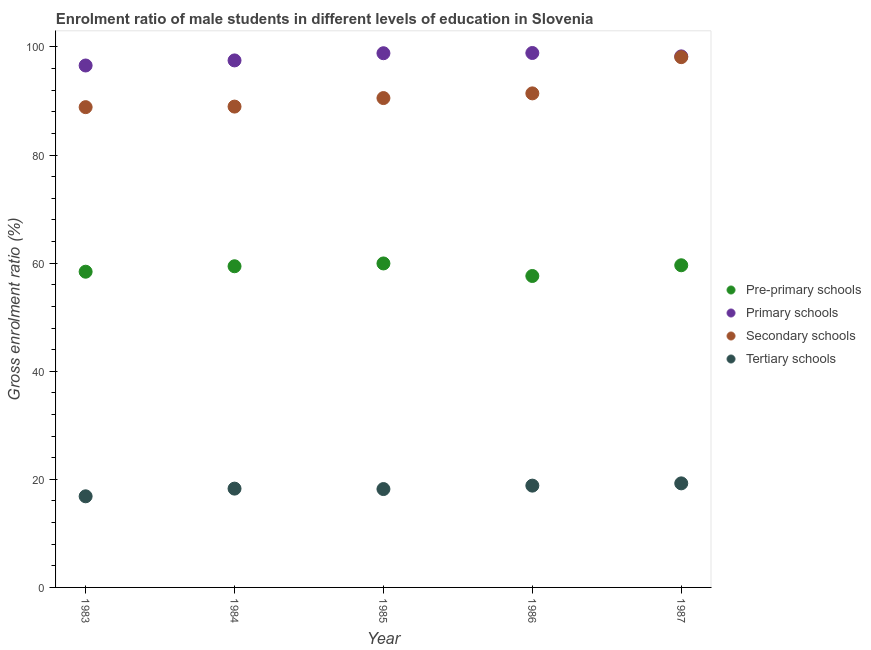How many different coloured dotlines are there?
Your response must be concise. 4. Is the number of dotlines equal to the number of legend labels?
Your answer should be very brief. Yes. What is the gross enrolment ratio(female) in tertiary schools in 1984?
Offer a very short reply. 18.28. Across all years, what is the maximum gross enrolment ratio(female) in primary schools?
Your response must be concise. 98.89. Across all years, what is the minimum gross enrolment ratio(female) in primary schools?
Your response must be concise. 96.58. In which year was the gross enrolment ratio(female) in secondary schools minimum?
Offer a terse response. 1983. What is the total gross enrolment ratio(female) in primary schools in the graph?
Offer a terse response. 490.1. What is the difference between the gross enrolment ratio(female) in pre-primary schools in 1984 and that in 1985?
Your response must be concise. -0.52. What is the difference between the gross enrolment ratio(female) in tertiary schools in 1987 and the gross enrolment ratio(female) in secondary schools in 1983?
Make the answer very short. -69.62. What is the average gross enrolment ratio(female) in primary schools per year?
Make the answer very short. 98.02. In the year 1986, what is the difference between the gross enrolment ratio(female) in tertiary schools and gross enrolment ratio(female) in pre-primary schools?
Make the answer very short. -38.79. In how many years, is the gross enrolment ratio(female) in pre-primary schools greater than 16 %?
Offer a terse response. 5. What is the ratio of the gross enrolment ratio(female) in pre-primary schools in 1984 to that in 1987?
Offer a terse response. 1. Is the difference between the gross enrolment ratio(female) in primary schools in 1984 and 1985 greater than the difference between the gross enrolment ratio(female) in secondary schools in 1984 and 1985?
Your answer should be compact. Yes. What is the difference between the highest and the second highest gross enrolment ratio(female) in primary schools?
Offer a terse response. 0.04. What is the difference between the highest and the lowest gross enrolment ratio(female) in secondary schools?
Ensure brevity in your answer.  9.25. In how many years, is the gross enrolment ratio(female) in tertiary schools greater than the average gross enrolment ratio(female) in tertiary schools taken over all years?
Offer a very short reply. 2. Does the gross enrolment ratio(female) in secondary schools monotonically increase over the years?
Keep it short and to the point. Yes. Is the gross enrolment ratio(female) in secondary schools strictly greater than the gross enrolment ratio(female) in pre-primary schools over the years?
Your response must be concise. Yes. How many years are there in the graph?
Give a very brief answer. 5. Are the values on the major ticks of Y-axis written in scientific E-notation?
Your answer should be very brief. No. How many legend labels are there?
Provide a succinct answer. 4. How are the legend labels stacked?
Provide a short and direct response. Vertical. What is the title of the graph?
Keep it short and to the point. Enrolment ratio of male students in different levels of education in Slovenia. Does "Secondary general education" appear as one of the legend labels in the graph?
Your answer should be compact. No. What is the label or title of the Y-axis?
Provide a short and direct response. Gross enrolment ratio (%). What is the Gross enrolment ratio (%) of Pre-primary schools in 1983?
Give a very brief answer. 58.42. What is the Gross enrolment ratio (%) in Primary schools in 1983?
Ensure brevity in your answer.  96.58. What is the Gross enrolment ratio (%) in Secondary schools in 1983?
Your answer should be compact. 88.87. What is the Gross enrolment ratio (%) in Tertiary schools in 1983?
Make the answer very short. 16.86. What is the Gross enrolment ratio (%) of Pre-primary schools in 1984?
Keep it short and to the point. 59.43. What is the Gross enrolment ratio (%) in Primary schools in 1984?
Make the answer very short. 97.52. What is the Gross enrolment ratio (%) of Secondary schools in 1984?
Ensure brevity in your answer.  88.97. What is the Gross enrolment ratio (%) of Tertiary schools in 1984?
Provide a short and direct response. 18.28. What is the Gross enrolment ratio (%) in Pre-primary schools in 1985?
Offer a terse response. 59.95. What is the Gross enrolment ratio (%) in Primary schools in 1985?
Provide a short and direct response. 98.85. What is the Gross enrolment ratio (%) of Secondary schools in 1985?
Your answer should be compact. 90.55. What is the Gross enrolment ratio (%) of Tertiary schools in 1985?
Your response must be concise. 18.2. What is the Gross enrolment ratio (%) in Pre-primary schools in 1986?
Your answer should be compact. 57.63. What is the Gross enrolment ratio (%) in Primary schools in 1986?
Offer a terse response. 98.89. What is the Gross enrolment ratio (%) in Secondary schools in 1986?
Provide a succinct answer. 91.42. What is the Gross enrolment ratio (%) in Tertiary schools in 1986?
Offer a terse response. 18.84. What is the Gross enrolment ratio (%) of Pre-primary schools in 1987?
Make the answer very short. 59.61. What is the Gross enrolment ratio (%) in Primary schools in 1987?
Keep it short and to the point. 98.27. What is the Gross enrolment ratio (%) in Secondary schools in 1987?
Offer a very short reply. 98.12. What is the Gross enrolment ratio (%) of Tertiary schools in 1987?
Your response must be concise. 19.25. Across all years, what is the maximum Gross enrolment ratio (%) of Pre-primary schools?
Provide a succinct answer. 59.95. Across all years, what is the maximum Gross enrolment ratio (%) in Primary schools?
Give a very brief answer. 98.89. Across all years, what is the maximum Gross enrolment ratio (%) in Secondary schools?
Provide a succinct answer. 98.12. Across all years, what is the maximum Gross enrolment ratio (%) of Tertiary schools?
Your response must be concise. 19.25. Across all years, what is the minimum Gross enrolment ratio (%) in Pre-primary schools?
Ensure brevity in your answer.  57.63. Across all years, what is the minimum Gross enrolment ratio (%) in Primary schools?
Make the answer very short. 96.58. Across all years, what is the minimum Gross enrolment ratio (%) of Secondary schools?
Offer a very short reply. 88.87. Across all years, what is the minimum Gross enrolment ratio (%) of Tertiary schools?
Ensure brevity in your answer.  16.86. What is the total Gross enrolment ratio (%) in Pre-primary schools in the graph?
Your answer should be very brief. 295.04. What is the total Gross enrolment ratio (%) in Primary schools in the graph?
Ensure brevity in your answer.  490.1. What is the total Gross enrolment ratio (%) of Secondary schools in the graph?
Your answer should be compact. 457.93. What is the total Gross enrolment ratio (%) in Tertiary schools in the graph?
Give a very brief answer. 91.44. What is the difference between the Gross enrolment ratio (%) of Pre-primary schools in 1983 and that in 1984?
Provide a succinct answer. -1.01. What is the difference between the Gross enrolment ratio (%) in Primary schools in 1983 and that in 1984?
Your answer should be very brief. -0.94. What is the difference between the Gross enrolment ratio (%) of Secondary schools in 1983 and that in 1984?
Provide a short and direct response. -0.1. What is the difference between the Gross enrolment ratio (%) of Tertiary schools in 1983 and that in 1984?
Ensure brevity in your answer.  -1.42. What is the difference between the Gross enrolment ratio (%) of Pre-primary schools in 1983 and that in 1985?
Provide a succinct answer. -1.53. What is the difference between the Gross enrolment ratio (%) of Primary schools in 1983 and that in 1985?
Offer a very short reply. -2.27. What is the difference between the Gross enrolment ratio (%) of Secondary schools in 1983 and that in 1985?
Your response must be concise. -1.68. What is the difference between the Gross enrolment ratio (%) of Tertiary schools in 1983 and that in 1985?
Give a very brief answer. -1.34. What is the difference between the Gross enrolment ratio (%) of Pre-primary schools in 1983 and that in 1986?
Your response must be concise. 0.79. What is the difference between the Gross enrolment ratio (%) in Primary schools in 1983 and that in 1986?
Ensure brevity in your answer.  -2.31. What is the difference between the Gross enrolment ratio (%) in Secondary schools in 1983 and that in 1986?
Provide a succinct answer. -2.55. What is the difference between the Gross enrolment ratio (%) of Tertiary schools in 1983 and that in 1986?
Your response must be concise. -1.97. What is the difference between the Gross enrolment ratio (%) in Pre-primary schools in 1983 and that in 1987?
Your answer should be very brief. -1.19. What is the difference between the Gross enrolment ratio (%) in Primary schools in 1983 and that in 1987?
Give a very brief answer. -1.69. What is the difference between the Gross enrolment ratio (%) of Secondary schools in 1983 and that in 1987?
Your response must be concise. -9.25. What is the difference between the Gross enrolment ratio (%) in Tertiary schools in 1983 and that in 1987?
Make the answer very short. -2.39. What is the difference between the Gross enrolment ratio (%) in Pre-primary schools in 1984 and that in 1985?
Provide a succinct answer. -0.52. What is the difference between the Gross enrolment ratio (%) in Primary schools in 1984 and that in 1985?
Keep it short and to the point. -1.33. What is the difference between the Gross enrolment ratio (%) in Secondary schools in 1984 and that in 1985?
Provide a succinct answer. -1.58. What is the difference between the Gross enrolment ratio (%) of Tertiary schools in 1984 and that in 1985?
Your answer should be compact. 0.08. What is the difference between the Gross enrolment ratio (%) of Pre-primary schools in 1984 and that in 1986?
Keep it short and to the point. 1.8. What is the difference between the Gross enrolment ratio (%) in Primary schools in 1984 and that in 1986?
Keep it short and to the point. -1.37. What is the difference between the Gross enrolment ratio (%) of Secondary schools in 1984 and that in 1986?
Keep it short and to the point. -2.44. What is the difference between the Gross enrolment ratio (%) of Tertiary schools in 1984 and that in 1986?
Your response must be concise. -0.55. What is the difference between the Gross enrolment ratio (%) of Pre-primary schools in 1984 and that in 1987?
Provide a succinct answer. -0.18. What is the difference between the Gross enrolment ratio (%) of Primary schools in 1984 and that in 1987?
Your answer should be compact. -0.75. What is the difference between the Gross enrolment ratio (%) in Secondary schools in 1984 and that in 1987?
Give a very brief answer. -9.15. What is the difference between the Gross enrolment ratio (%) of Tertiary schools in 1984 and that in 1987?
Your answer should be very brief. -0.97. What is the difference between the Gross enrolment ratio (%) in Pre-primary schools in 1985 and that in 1986?
Your answer should be compact. 2.32. What is the difference between the Gross enrolment ratio (%) of Primary schools in 1985 and that in 1986?
Your response must be concise. -0.04. What is the difference between the Gross enrolment ratio (%) of Secondary schools in 1985 and that in 1986?
Keep it short and to the point. -0.87. What is the difference between the Gross enrolment ratio (%) in Tertiary schools in 1985 and that in 1986?
Your answer should be compact. -0.63. What is the difference between the Gross enrolment ratio (%) of Pre-primary schools in 1985 and that in 1987?
Your answer should be very brief. 0.34. What is the difference between the Gross enrolment ratio (%) in Primary schools in 1985 and that in 1987?
Keep it short and to the point. 0.58. What is the difference between the Gross enrolment ratio (%) in Secondary schools in 1985 and that in 1987?
Your response must be concise. -7.57. What is the difference between the Gross enrolment ratio (%) of Tertiary schools in 1985 and that in 1987?
Offer a very short reply. -1.05. What is the difference between the Gross enrolment ratio (%) of Pre-primary schools in 1986 and that in 1987?
Make the answer very short. -1.98. What is the difference between the Gross enrolment ratio (%) in Primary schools in 1986 and that in 1987?
Offer a terse response. 0.62. What is the difference between the Gross enrolment ratio (%) of Secondary schools in 1986 and that in 1987?
Give a very brief answer. -6.7. What is the difference between the Gross enrolment ratio (%) of Tertiary schools in 1986 and that in 1987?
Provide a succinct answer. -0.42. What is the difference between the Gross enrolment ratio (%) of Pre-primary schools in 1983 and the Gross enrolment ratio (%) of Primary schools in 1984?
Provide a short and direct response. -39.1. What is the difference between the Gross enrolment ratio (%) of Pre-primary schools in 1983 and the Gross enrolment ratio (%) of Secondary schools in 1984?
Give a very brief answer. -30.55. What is the difference between the Gross enrolment ratio (%) in Pre-primary schools in 1983 and the Gross enrolment ratio (%) in Tertiary schools in 1984?
Your answer should be compact. 40.14. What is the difference between the Gross enrolment ratio (%) of Primary schools in 1983 and the Gross enrolment ratio (%) of Secondary schools in 1984?
Provide a short and direct response. 7.6. What is the difference between the Gross enrolment ratio (%) in Primary schools in 1983 and the Gross enrolment ratio (%) in Tertiary schools in 1984?
Provide a succinct answer. 78.29. What is the difference between the Gross enrolment ratio (%) in Secondary schools in 1983 and the Gross enrolment ratio (%) in Tertiary schools in 1984?
Your answer should be very brief. 70.59. What is the difference between the Gross enrolment ratio (%) of Pre-primary schools in 1983 and the Gross enrolment ratio (%) of Primary schools in 1985?
Offer a terse response. -40.43. What is the difference between the Gross enrolment ratio (%) of Pre-primary schools in 1983 and the Gross enrolment ratio (%) of Secondary schools in 1985?
Ensure brevity in your answer.  -32.13. What is the difference between the Gross enrolment ratio (%) in Pre-primary schools in 1983 and the Gross enrolment ratio (%) in Tertiary schools in 1985?
Your response must be concise. 40.22. What is the difference between the Gross enrolment ratio (%) in Primary schools in 1983 and the Gross enrolment ratio (%) in Secondary schools in 1985?
Provide a succinct answer. 6.03. What is the difference between the Gross enrolment ratio (%) of Primary schools in 1983 and the Gross enrolment ratio (%) of Tertiary schools in 1985?
Ensure brevity in your answer.  78.38. What is the difference between the Gross enrolment ratio (%) of Secondary schools in 1983 and the Gross enrolment ratio (%) of Tertiary schools in 1985?
Offer a terse response. 70.67. What is the difference between the Gross enrolment ratio (%) of Pre-primary schools in 1983 and the Gross enrolment ratio (%) of Primary schools in 1986?
Ensure brevity in your answer.  -40.47. What is the difference between the Gross enrolment ratio (%) in Pre-primary schools in 1983 and the Gross enrolment ratio (%) in Secondary schools in 1986?
Your response must be concise. -33. What is the difference between the Gross enrolment ratio (%) in Pre-primary schools in 1983 and the Gross enrolment ratio (%) in Tertiary schools in 1986?
Offer a very short reply. 39.58. What is the difference between the Gross enrolment ratio (%) in Primary schools in 1983 and the Gross enrolment ratio (%) in Secondary schools in 1986?
Your answer should be very brief. 5.16. What is the difference between the Gross enrolment ratio (%) of Primary schools in 1983 and the Gross enrolment ratio (%) of Tertiary schools in 1986?
Make the answer very short. 77.74. What is the difference between the Gross enrolment ratio (%) of Secondary schools in 1983 and the Gross enrolment ratio (%) of Tertiary schools in 1986?
Provide a succinct answer. 70.03. What is the difference between the Gross enrolment ratio (%) in Pre-primary schools in 1983 and the Gross enrolment ratio (%) in Primary schools in 1987?
Your answer should be very brief. -39.85. What is the difference between the Gross enrolment ratio (%) in Pre-primary schools in 1983 and the Gross enrolment ratio (%) in Secondary schools in 1987?
Offer a terse response. -39.7. What is the difference between the Gross enrolment ratio (%) in Pre-primary schools in 1983 and the Gross enrolment ratio (%) in Tertiary schools in 1987?
Make the answer very short. 39.17. What is the difference between the Gross enrolment ratio (%) of Primary schools in 1983 and the Gross enrolment ratio (%) of Secondary schools in 1987?
Make the answer very short. -1.54. What is the difference between the Gross enrolment ratio (%) of Primary schools in 1983 and the Gross enrolment ratio (%) of Tertiary schools in 1987?
Your answer should be compact. 77.32. What is the difference between the Gross enrolment ratio (%) in Secondary schools in 1983 and the Gross enrolment ratio (%) in Tertiary schools in 1987?
Keep it short and to the point. 69.61. What is the difference between the Gross enrolment ratio (%) of Pre-primary schools in 1984 and the Gross enrolment ratio (%) of Primary schools in 1985?
Your answer should be compact. -39.42. What is the difference between the Gross enrolment ratio (%) in Pre-primary schools in 1984 and the Gross enrolment ratio (%) in Secondary schools in 1985?
Your answer should be compact. -31.12. What is the difference between the Gross enrolment ratio (%) of Pre-primary schools in 1984 and the Gross enrolment ratio (%) of Tertiary schools in 1985?
Provide a succinct answer. 41.23. What is the difference between the Gross enrolment ratio (%) of Primary schools in 1984 and the Gross enrolment ratio (%) of Secondary schools in 1985?
Provide a short and direct response. 6.97. What is the difference between the Gross enrolment ratio (%) in Primary schools in 1984 and the Gross enrolment ratio (%) in Tertiary schools in 1985?
Keep it short and to the point. 79.31. What is the difference between the Gross enrolment ratio (%) of Secondary schools in 1984 and the Gross enrolment ratio (%) of Tertiary schools in 1985?
Provide a succinct answer. 70.77. What is the difference between the Gross enrolment ratio (%) in Pre-primary schools in 1984 and the Gross enrolment ratio (%) in Primary schools in 1986?
Offer a terse response. -39.46. What is the difference between the Gross enrolment ratio (%) in Pre-primary schools in 1984 and the Gross enrolment ratio (%) in Secondary schools in 1986?
Your response must be concise. -31.99. What is the difference between the Gross enrolment ratio (%) of Pre-primary schools in 1984 and the Gross enrolment ratio (%) of Tertiary schools in 1986?
Your response must be concise. 40.59. What is the difference between the Gross enrolment ratio (%) of Primary schools in 1984 and the Gross enrolment ratio (%) of Secondary schools in 1986?
Your answer should be compact. 6.1. What is the difference between the Gross enrolment ratio (%) in Primary schools in 1984 and the Gross enrolment ratio (%) in Tertiary schools in 1986?
Your answer should be compact. 78.68. What is the difference between the Gross enrolment ratio (%) of Secondary schools in 1984 and the Gross enrolment ratio (%) of Tertiary schools in 1986?
Your answer should be very brief. 70.14. What is the difference between the Gross enrolment ratio (%) in Pre-primary schools in 1984 and the Gross enrolment ratio (%) in Primary schools in 1987?
Give a very brief answer. -38.84. What is the difference between the Gross enrolment ratio (%) of Pre-primary schools in 1984 and the Gross enrolment ratio (%) of Secondary schools in 1987?
Provide a succinct answer. -38.69. What is the difference between the Gross enrolment ratio (%) of Pre-primary schools in 1984 and the Gross enrolment ratio (%) of Tertiary schools in 1987?
Your response must be concise. 40.17. What is the difference between the Gross enrolment ratio (%) of Primary schools in 1984 and the Gross enrolment ratio (%) of Secondary schools in 1987?
Provide a short and direct response. -0.6. What is the difference between the Gross enrolment ratio (%) of Primary schools in 1984 and the Gross enrolment ratio (%) of Tertiary schools in 1987?
Provide a short and direct response. 78.26. What is the difference between the Gross enrolment ratio (%) in Secondary schools in 1984 and the Gross enrolment ratio (%) in Tertiary schools in 1987?
Provide a short and direct response. 69.72. What is the difference between the Gross enrolment ratio (%) of Pre-primary schools in 1985 and the Gross enrolment ratio (%) of Primary schools in 1986?
Ensure brevity in your answer.  -38.94. What is the difference between the Gross enrolment ratio (%) in Pre-primary schools in 1985 and the Gross enrolment ratio (%) in Secondary schools in 1986?
Make the answer very short. -31.47. What is the difference between the Gross enrolment ratio (%) in Pre-primary schools in 1985 and the Gross enrolment ratio (%) in Tertiary schools in 1986?
Offer a terse response. 41.11. What is the difference between the Gross enrolment ratio (%) of Primary schools in 1985 and the Gross enrolment ratio (%) of Secondary schools in 1986?
Provide a succinct answer. 7.43. What is the difference between the Gross enrolment ratio (%) of Primary schools in 1985 and the Gross enrolment ratio (%) of Tertiary schools in 1986?
Keep it short and to the point. 80.01. What is the difference between the Gross enrolment ratio (%) in Secondary schools in 1985 and the Gross enrolment ratio (%) in Tertiary schools in 1986?
Ensure brevity in your answer.  71.71. What is the difference between the Gross enrolment ratio (%) of Pre-primary schools in 1985 and the Gross enrolment ratio (%) of Primary schools in 1987?
Your response must be concise. -38.32. What is the difference between the Gross enrolment ratio (%) of Pre-primary schools in 1985 and the Gross enrolment ratio (%) of Secondary schools in 1987?
Your response must be concise. -38.17. What is the difference between the Gross enrolment ratio (%) in Pre-primary schools in 1985 and the Gross enrolment ratio (%) in Tertiary schools in 1987?
Provide a short and direct response. 40.69. What is the difference between the Gross enrolment ratio (%) of Primary schools in 1985 and the Gross enrolment ratio (%) of Secondary schools in 1987?
Provide a succinct answer. 0.73. What is the difference between the Gross enrolment ratio (%) of Primary schools in 1985 and the Gross enrolment ratio (%) of Tertiary schools in 1987?
Keep it short and to the point. 79.59. What is the difference between the Gross enrolment ratio (%) in Secondary schools in 1985 and the Gross enrolment ratio (%) in Tertiary schools in 1987?
Your answer should be very brief. 71.3. What is the difference between the Gross enrolment ratio (%) of Pre-primary schools in 1986 and the Gross enrolment ratio (%) of Primary schools in 1987?
Ensure brevity in your answer.  -40.64. What is the difference between the Gross enrolment ratio (%) of Pre-primary schools in 1986 and the Gross enrolment ratio (%) of Secondary schools in 1987?
Offer a terse response. -40.49. What is the difference between the Gross enrolment ratio (%) in Pre-primary schools in 1986 and the Gross enrolment ratio (%) in Tertiary schools in 1987?
Provide a short and direct response. 38.37. What is the difference between the Gross enrolment ratio (%) in Primary schools in 1986 and the Gross enrolment ratio (%) in Secondary schools in 1987?
Offer a very short reply. 0.77. What is the difference between the Gross enrolment ratio (%) of Primary schools in 1986 and the Gross enrolment ratio (%) of Tertiary schools in 1987?
Make the answer very short. 79.64. What is the difference between the Gross enrolment ratio (%) of Secondary schools in 1986 and the Gross enrolment ratio (%) of Tertiary schools in 1987?
Ensure brevity in your answer.  72.16. What is the average Gross enrolment ratio (%) of Pre-primary schools per year?
Your response must be concise. 59.01. What is the average Gross enrolment ratio (%) in Primary schools per year?
Your answer should be very brief. 98.02. What is the average Gross enrolment ratio (%) of Secondary schools per year?
Provide a short and direct response. 91.59. What is the average Gross enrolment ratio (%) of Tertiary schools per year?
Offer a very short reply. 18.29. In the year 1983, what is the difference between the Gross enrolment ratio (%) in Pre-primary schools and Gross enrolment ratio (%) in Primary schools?
Your answer should be compact. -38.16. In the year 1983, what is the difference between the Gross enrolment ratio (%) in Pre-primary schools and Gross enrolment ratio (%) in Secondary schools?
Ensure brevity in your answer.  -30.45. In the year 1983, what is the difference between the Gross enrolment ratio (%) in Pre-primary schools and Gross enrolment ratio (%) in Tertiary schools?
Make the answer very short. 41.56. In the year 1983, what is the difference between the Gross enrolment ratio (%) in Primary schools and Gross enrolment ratio (%) in Secondary schools?
Offer a very short reply. 7.71. In the year 1983, what is the difference between the Gross enrolment ratio (%) of Primary schools and Gross enrolment ratio (%) of Tertiary schools?
Your response must be concise. 79.72. In the year 1983, what is the difference between the Gross enrolment ratio (%) of Secondary schools and Gross enrolment ratio (%) of Tertiary schools?
Provide a short and direct response. 72.01. In the year 1984, what is the difference between the Gross enrolment ratio (%) of Pre-primary schools and Gross enrolment ratio (%) of Primary schools?
Your answer should be compact. -38.09. In the year 1984, what is the difference between the Gross enrolment ratio (%) of Pre-primary schools and Gross enrolment ratio (%) of Secondary schools?
Offer a very short reply. -29.54. In the year 1984, what is the difference between the Gross enrolment ratio (%) in Pre-primary schools and Gross enrolment ratio (%) in Tertiary schools?
Provide a short and direct response. 41.15. In the year 1984, what is the difference between the Gross enrolment ratio (%) in Primary schools and Gross enrolment ratio (%) in Secondary schools?
Your response must be concise. 8.54. In the year 1984, what is the difference between the Gross enrolment ratio (%) of Primary schools and Gross enrolment ratio (%) of Tertiary schools?
Provide a short and direct response. 79.23. In the year 1984, what is the difference between the Gross enrolment ratio (%) of Secondary schools and Gross enrolment ratio (%) of Tertiary schools?
Provide a succinct answer. 70.69. In the year 1985, what is the difference between the Gross enrolment ratio (%) in Pre-primary schools and Gross enrolment ratio (%) in Primary schools?
Your response must be concise. -38.9. In the year 1985, what is the difference between the Gross enrolment ratio (%) of Pre-primary schools and Gross enrolment ratio (%) of Secondary schools?
Provide a succinct answer. -30.6. In the year 1985, what is the difference between the Gross enrolment ratio (%) of Pre-primary schools and Gross enrolment ratio (%) of Tertiary schools?
Make the answer very short. 41.75. In the year 1985, what is the difference between the Gross enrolment ratio (%) of Primary schools and Gross enrolment ratio (%) of Secondary schools?
Give a very brief answer. 8.3. In the year 1985, what is the difference between the Gross enrolment ratio (%) in Primary schools and Gross enrolment ratio (%) in Tertiary schools?
Give a very brief answer. 80.65. In the year 1985, what is the difference between the Gross enrolment ratio (%) in Secondary schools and Gross enrolment ratio (%) in Tertiary schools?
Offer a terse response. 72.35. In the year 1986, what is the difference between the Gross enrolment ratio (%) in Pre-primary schools and Gross enrolment ratio (%) in Primary schools?
Ensure brevity in your answer.  -41.26. In the year 1986, what is the difference between the Gross enrolment ratio (%) of Pre-primary schools and Gross enrolment ratio (%) of Secondary schools?
Offer a very short reply. -33.79. In the year 1986, what is the difference between the Gross enrolment ratio (%) of Pre-primary schools and Gross enrolment ratio (%) of Tertiary schools?
Your answer should be compact. 38.79. In the year 1986, what is the difference between the Gross enrolment ratio (%) of Primary schools and Gross enrolment ratio (%) of Secondary schools?
Keep it short and to the point. 7.47. In the year 1986, what is the difference between the Gross enrolment ratio (%) of Primary schools and Gross enrolment ratio (%) of Tertiary schools?
Ensure brevity in your answer.  80.06. In the year 1986, what is the difference between the Gross enrolment ratio (%) in Secondary schools and Gross enrolment ratio (%) in Tertiary schools?
Your answer should be very brief. 72.58. In the year 1987, what is the difference between the Gross enrolment ratio (%) in Pre-primary schools and Gross enrolment ratio (%) in Primary schools?
Offer a very short reply. -38.65. In the year 1987, what is the difference between the Gross enrolment ratio (%) of Pre-primary schools and Gross enrolment ratio (%) of Secondary schools?
Provide a short and direct response. -38.51. In the year 1987, what is the difference between the Gross enrolment ratio (%) in Pre-primary schools and Gross enrolment ratio (%) in Tertiary schools?
Ensure brevity in your answer.  40.36. In the year 1987, what is the difference between the Gross enrolment ratio (%) of Primary schools and Gross enrolment ratio (%) of Secondary schools?
Provide a short and direct response. 0.15. In the year 1987, what is the difference between the Gross enrolment ratio (%) in Primary schools and Gross enrolment ratio (%) in Tertiary schools?
Keep it short and to the point. 79.01. In the year 1987, what is the difference between the Gross enrolment ratio (%) of Secondary schools and Gross enrolment ratio (%) of Tertiary schools?
Give a very brief answer. 78.87. What is the ratio of the Gross enrolment ratio (%) in Primary schools in 1983 to that in 1984?
Keep it short and to the point. 0.99. What is the ratio of the Gross enrolment ratio (%) in Secondary schools in 1983 to that in 1984?
Offer a terse response. 1. What is the ratio of the Gross enrolment ratio (%) of Tertiary schools in 1983 to that in 1984?
Ensure brevity in your answer.  0.92. What is the ratio of the Gross enrolment ratio (%) in Pre-primary schools in 1983 to that in 1985?
Ensure brevity in your answer.  0.97. What is the ratio of the Gross enrolment ratio (%) of Secondary schools in 1983 to that in 1985?
Your answer should be compact. 0.98. What is the ratio of the Gross enrolment ratio (%) in Tertiary schools in 1983 to that in 1985?
Make the answer very short. 0.93. What is the ratio of the Gross enrolment ratio (%) of Pre-primary schools in 1983 to that in 1986?
Your answer should be compact. 1.01. What is the ratio of the Gross enrolment ratio (%) of Primary schools in 1983 to that in 1986?
Offer a very short reply. 0.98. What is the ratio of the Gross enrolment ratio (%) of Secondary schools in 1983 to that in 1986?
Make the answer very short. 0.97. What is the ratio of the Gross enrolment ratio (%) of Tertiary schools in 1983 to that in 1986?
Give a very brief answer. 0.9. What is the ratio of the Gross enrolment ratio (%) of Primary schools in 1983 to that in 1987?
Your response must be concise. 0.98. What is the ratio of the Gross enrolment ratio (%) in Secondary schools in 1983 to that in 1987?
Make the answer very short. 0.91. What is the ratio of the Gross enrolment ratio (%) in Tertiary schools in 1983 to that in 1987?
Offer a very short reply. 0.88. What is the ratio of the Gross enrolment ratio (%) of Pre-primary schools in 1984 to that in 1985?
Ensure brevity in your answer.  0.99. What is the ratio of the Gross enrolment ratio (%) in Primary schools in 1984 to that in 1985?
Provide a short and direct response. 0.99. What is the ratio of the Gross enrolment ratio (%) of Secondary schools in 1984 to that in 1985?
Offer a very short reply. 0.98. What is the ratio of the Gross enrolment ratio (%) of Tertiary schools in 1984 to that in 1985?
Make the answer very short. 1. What is the ratio of the Gross enrolment ratio (%) of Pre-primary schools in 1984 to that in 1986?
Provide a succinct answer. 1.03. What is the ratio of the Gross enrolment ratio (%) of Primary schools in 1984 to that in 1986?
Your answer should be compact. 0.99. What is the ratio of the Gross enrolment ratio (%) of Secondary schools in 1984 to that in 1986?
Provide a short and direct response. 0.97. What is the ratio of the Gross enrolment ratio (%) of Tertiary schools in 1984 to that in 1986?
Your answer should be compact. 0.97. What is the ratio of the Gross enrolment ratio (%) in Pre-primary schools in 1984 to that in 1987?
Provide a short and direct response. 1. What is the ratio of the Gross enrolment ratio (%) of Primary schools in 1984 to that in 1987?
Ensure brevity in your answer.  0.99. What is the ratio of the Gross enrolment ratio (%) in Secondary schools in 1984 to that in 1987?
Keep it short and to the point. 0.91. What is the ratio of the Gross enrolment ratio (%) of Tertiary schools in 1984 to that in 1987?
Your response must be concise. 0.95. What is the ratio of the Gross enrolment ratio (%) of Pre-primary schools in 1985 to that in 1986?
Ensure brevity in your answer.  1.04. What is the ratio of the Gross enrolment ratio (%) in Secondary schools in 1985 to that in 1986?
Ensure brevity in your answer.  0.99. What is the ratio of the Gross enrolment ratio (%) of Tertiary schools in 1985 to that in 1986?
Your answer should be compact. 0.97. What is the ratio of the Gross enrolment ratio (%) of Pre-primary schools in 1985 to that in 1987?
Give a very brief answer. 1.01. What is the ratio of the Gross enrolment ratio (%) of Primary schools in 1985 to that in 1987?
Give a very brief answer. 1.01. What is the ratio of the Gross enrolment ratio (%) of Secondary schools in 1985 to that in 1987?
Provide a short and direct response. 0.92. What is the ratio of the Gross enrolment ratio (%) of Tertiary schools in 1985 to that in 1987?
Your answer should be compact. 0.95. What is the ratio of the Gross enrolment ratio (%) in Pre-primary schools in 1986 to that in 1987?
Provide a short and direct response. 0.97. What is the ratio of the Gross enrolment ratio (%) of Primary schools in 1986 to that in 1987?
Your answer should be compact. 1.01. What is the ratio of the Gross enrolment ratio (%) of Secondary schools in 1986 to that in 1987?
Offer a very short reply. 0.93. What is the ratio of the Gross enrolment ratio (%) in Tertiary schools in 1986 to that in 1987?
Your answer should be very brief. 0.98. What is the difference between the highest and the second highest Gross enrolment ratio (%) of Pre-primary schools?
Your answer should be very brief. 0.34. What is the difference between the highest and the second highest Gross enrolment ratio (%) of Primary schools?
Offer a very short reply. 0.04. What is the difference between the highest and the second highest Gross enrolment ratio (%) of Secondary schools?
Provide a succinct answer. 6.7. What is the difference between the highest and the second highest Gross enrolment ratio (%) of Tertiary schools?
Ensure brevity in your answer.  0.42. What is the difference between the highest and the lowest Gross enrolment ratio (%) of Pre-primary schools?
Provide a succinct answer. 2.32. What is the difference between the highest and the lowest Gross enrolment ratio (%) of Primary schools?
Provide a short and direct response. 2.31. What is the difference between the highest and the lowest Gross enrolment ratio (%) of Secondary schools?
Keep it short and to the point. 9.25. What is the difference between the highest and the lowest Gross enrolment ratio (%) of Tertiary schools?
Give a very brief answer. 2.39. 